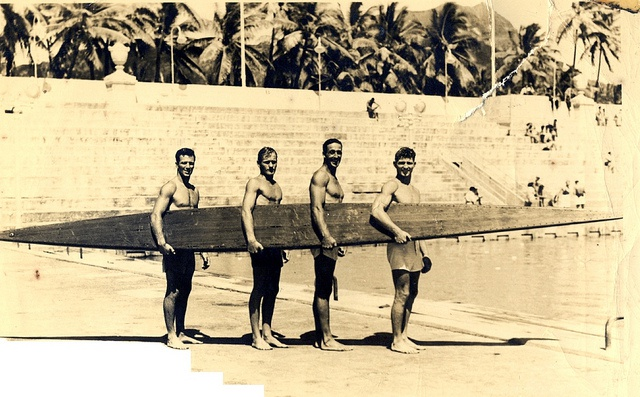Describe the objects in this image and their specific colors. I can see surfboard in khaki, gray, black, and tan tones, people in khaki, black, tan, and gray tones, people in khaki, tan, black, and gray tones, people in khaki, black, tan, and gray tones, and people in khaki, black, and tan tones in this image. 